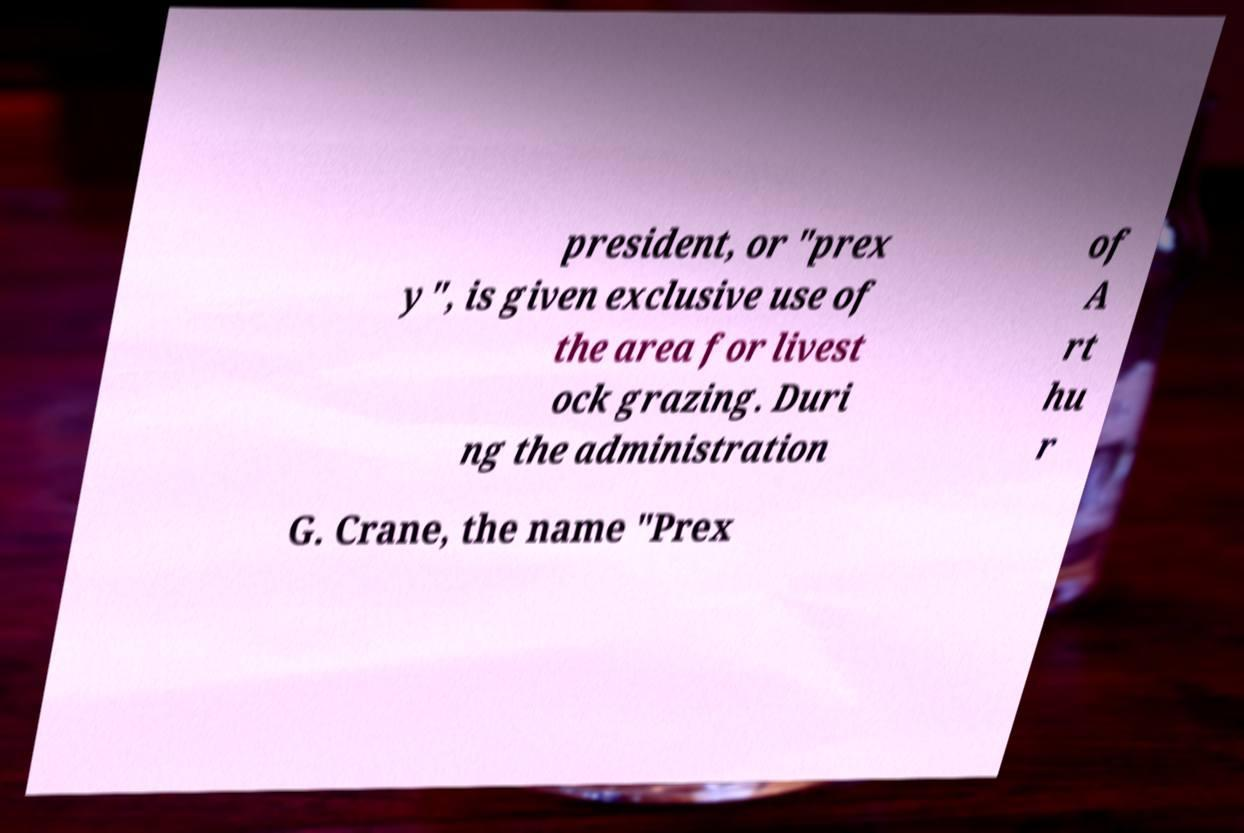Please identify and transcribe the text found in this image. president, or "prex y", is given exclusive use of the area for livest ock grazing. Duri ng the administration of A rt hu r G. Crane, the name "Prex 